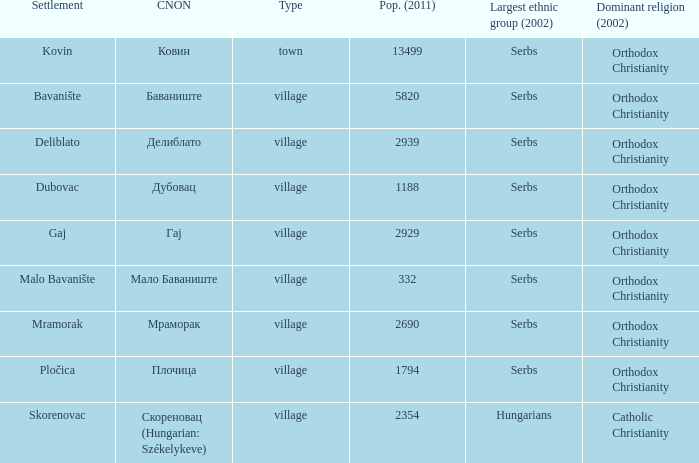What is the Deliblato village known as in Cyrillic? Делиблато. 